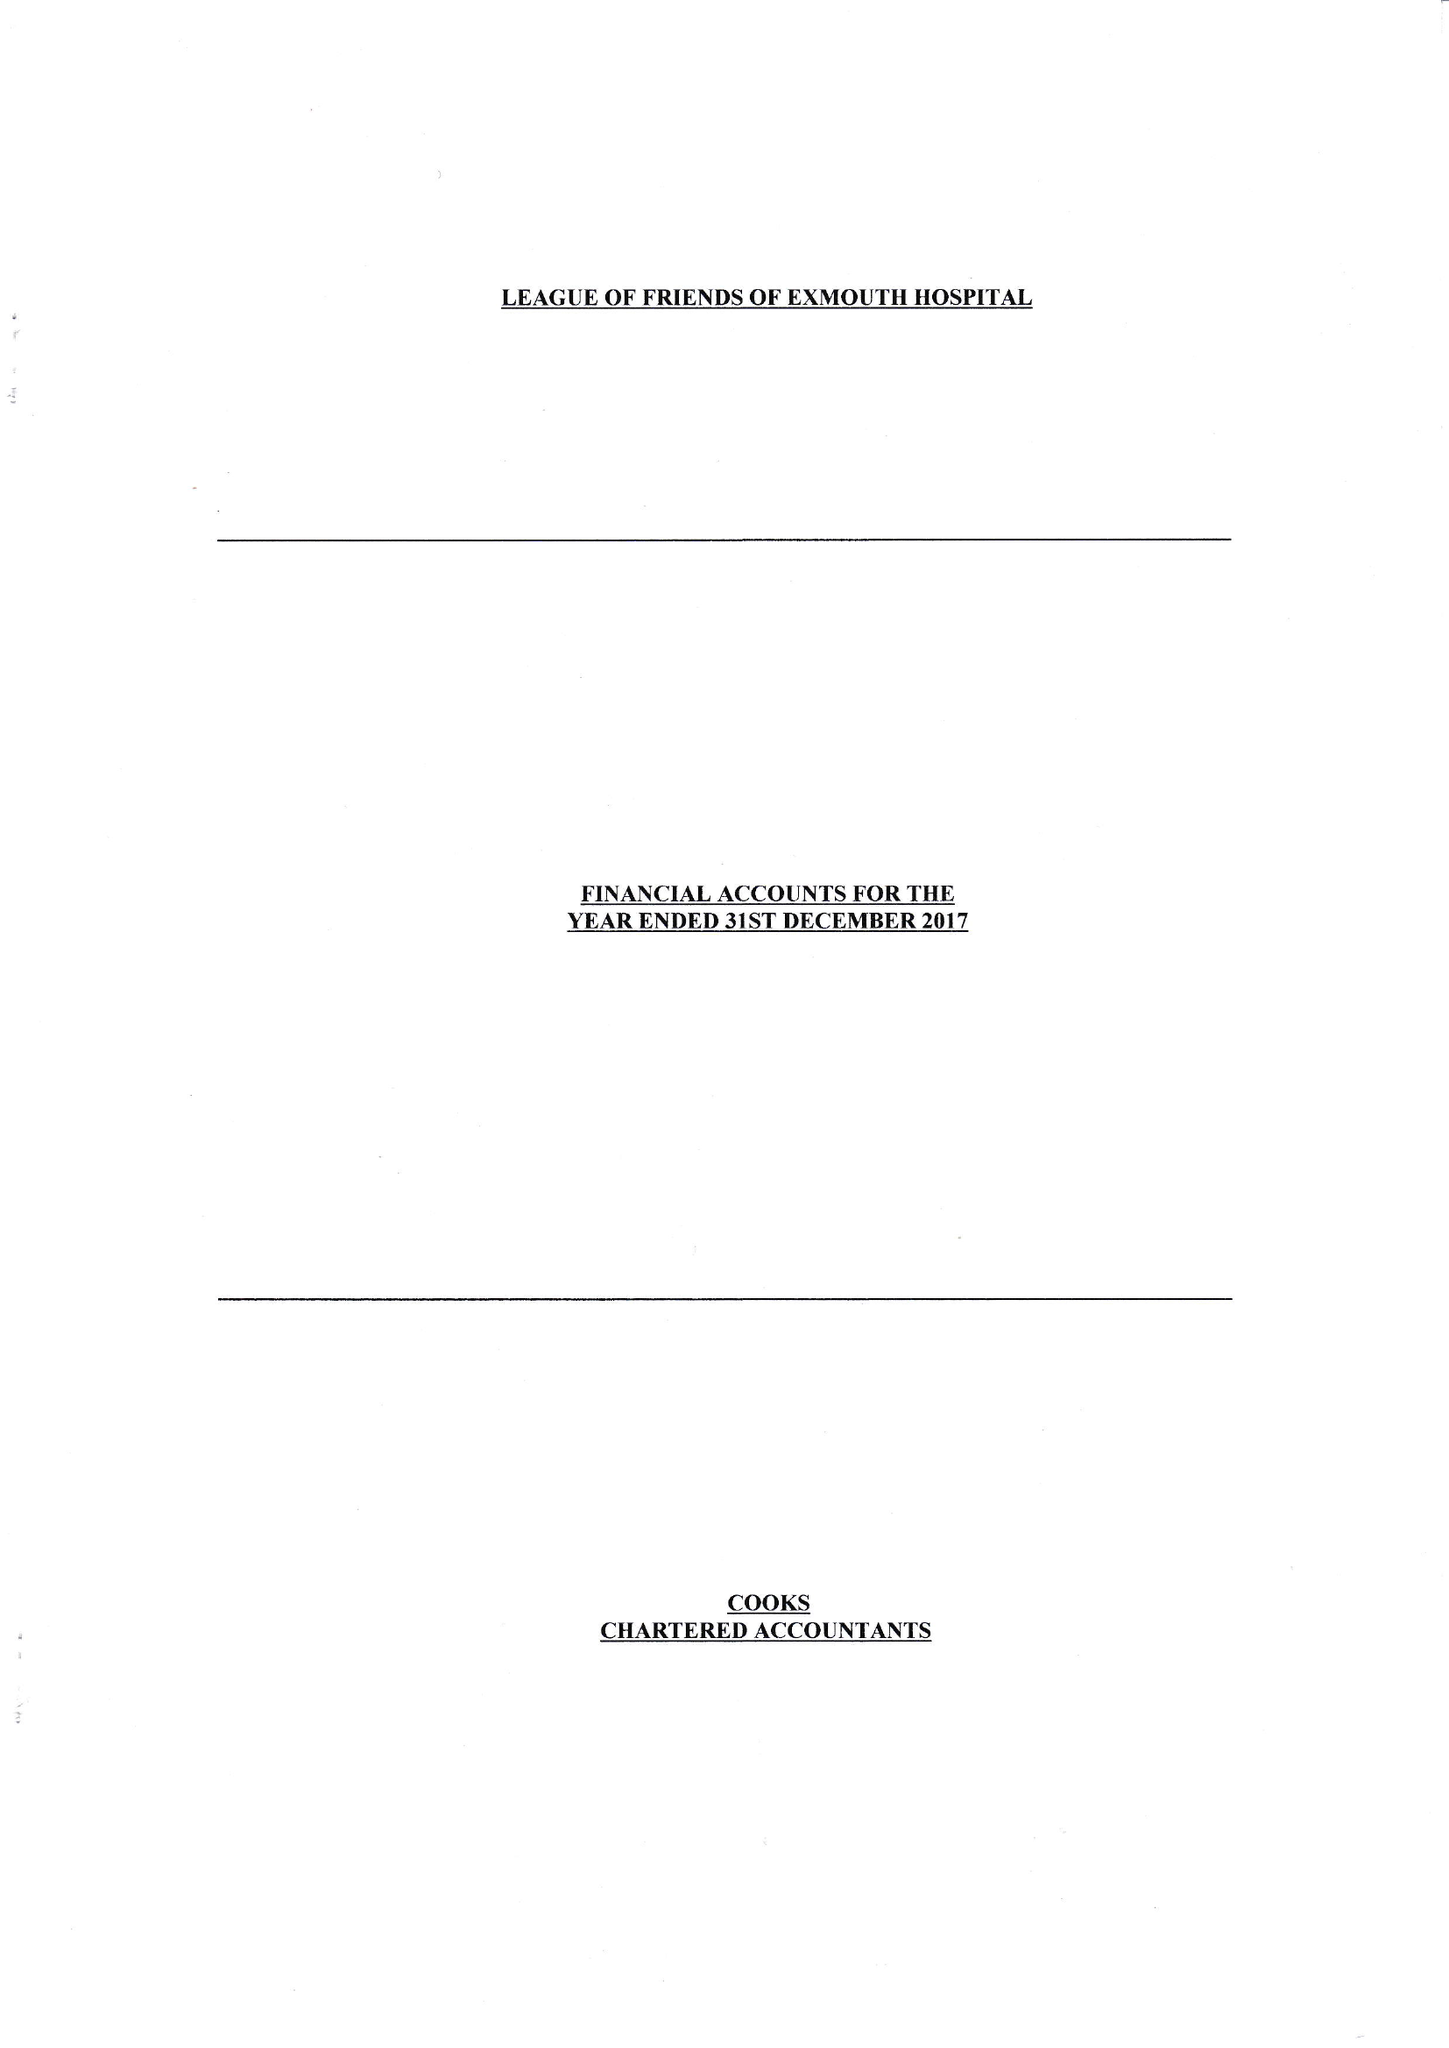What is the value for the address__postcode?
Answer the question using a single word or phrase. EX8 2JN 